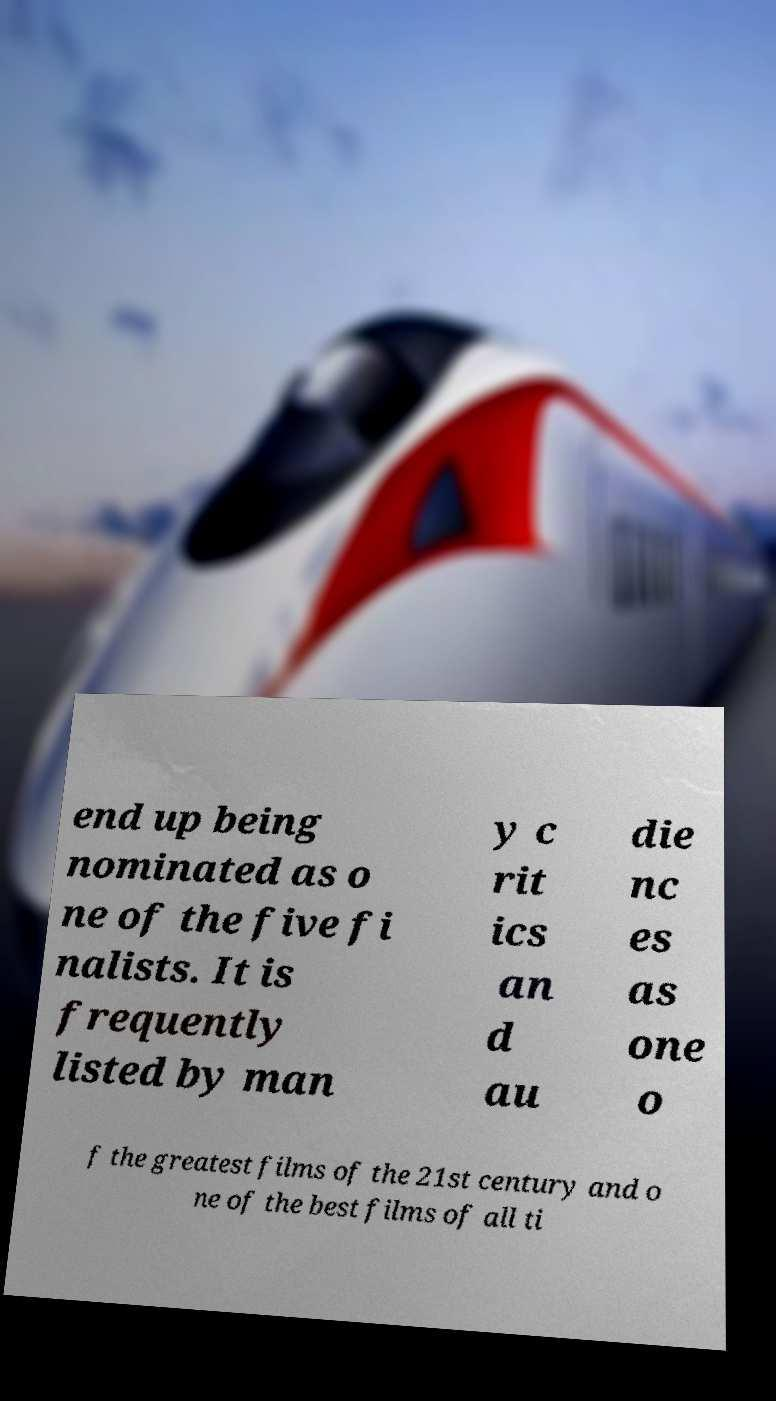Please read and relay the text visible in this image. What does it say? end up being nominated as o ne of the five fi nalists. It is frequently listed by man y c rit ics an d au die nc es as one o f the greatest films of the 21st century and o ne of the best films of all ti 